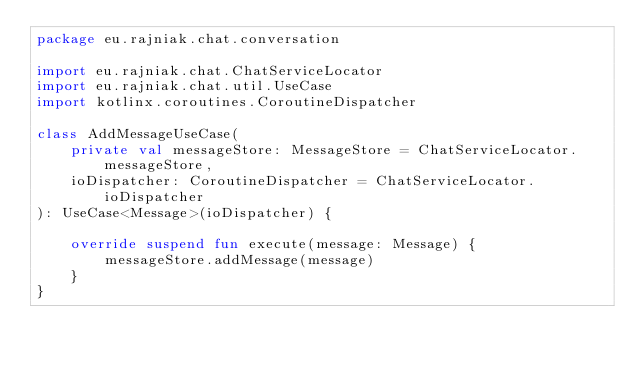Convert code to text. <code><loc_0><loc_0><loc_500><loc_500><_Kotlin_>package eu.rajniak.chat.conversation

import eu.rajniak.chat.ChatServiceLocator
import eu.rajniak.chat.util.UseCase
import kotlinx.coroutines.CoroutineDispatcher

class AddMessageUseCase(
    private val messageStore: MessageStore = ChatServiceLocator.messageStore,
    ioDispatcher: CoroutineDispatcher = ChatServiceLocator.ioDispatcher
): UseCase<Message>(ioDispatcher) {

    override suspend fun execute(message: Message) {
        messageStore.addMessage(message)
    }
}
</code> 